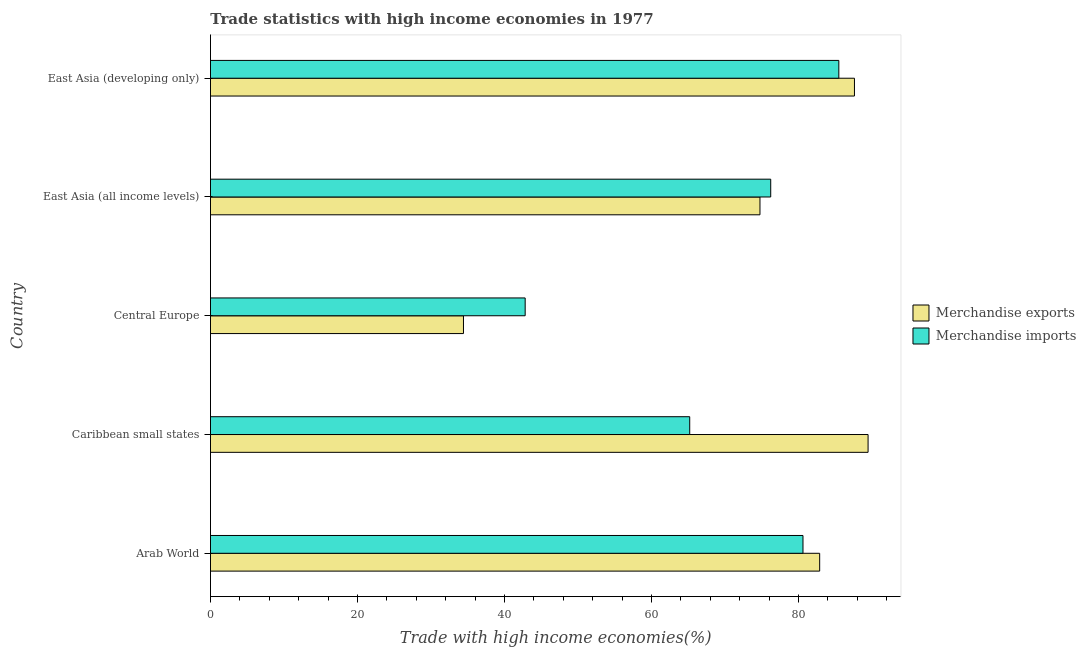How many different coloured bars are there?
Offer a terse response. 2. Are the number of bars per tick equal to the number of legend labels?
Your answer should be very brief. Yes. How many bars are there on the 3rd tick from the top?
Your answer should be compact. 2. What is the label of the 4th group of bars from the top?
Ensure brevity in your answer.  Caribbean small states. In how many cases, is the number of bars for a given country not equal to the number of legend labels?
Offer a very short reply. 0. What is the merchandise exports in East Asia (developing only)?
Offer a very short reply. 87.6. Across all countries, what is the maximum merchandise imports?
Provide a short and direct response. 85.48. Across all countries, what is the minimum merchandise imports?
Offer a very short reply. 42.81. In which country was the merchandise imports maximum?
Ensure brevity in your answer.  East Asia (developing only). In which country was the merchandise imports minimum?
Give a very brief answer. Central Europe. What is the total merchandise imports in the graph?
Offer a terse response. 350.3. What is the difference between the merchandise exports in Arab World and that in Caribbean small states?
Your answer should be very brief. -6.58. What is the difference between the merchandise imports in Central Europe and the merchandise exports in Arab World?
Your answer should be compact. -40.06. What is the average merchandise exports per country?
Provide a short and direct response. 73.82. What is the difference between the merchandise imports and merchandise exports in Arab World?
Keep it short and to the point. -2.27. In how many countries, is the merchandise exports greater than 28 %?
Your answer should be compact. 5. What is the ratio of the merchandise exports in Caribbean small states to that in East Asia (all income levels)?
Make the answer very short. 1.2. Is the difference between the merchandise imports in Caribbean small states and East Asia (developing only) greater than the difference between the merchandise exports in Caribbean small states and East Asia (developing only)?
Your response must be concise. No. What is the difference between the highest and the second highest merchandise exports?
Make the answer very short. 1.85. What is the difference between the highest and the lowest merchandise exports?
Offer a terse response. 55.04. Is the sum of the merchandise exports in Central Europe and East Asia (all income levels) greater than the maximum merchandise imports across all countries?
Your answer should be very brief. Yes. What does the 2nd bar from the top in Central Europe represents?
Provide a succinct answer. Merchandise exports. How many countries are there in the graph?
Your answer should be compact. 5. Does the graph contain any zero values?
Give a very brief answer. No. Where does the legend appear in the graph?
Offer a terse response. Center right. What is the title of the graph?
Give a very brief answer. Trade statistics with high income economies in 1977. Does "Broad money growth" appear as one of the legend labels in the graph?
Your response must be concise. No. What is the label or title of the X-axis?
Provide a short and direct response. Trade with high income economies(%). What is the label or title of the Y-axis?
Your answer should be very brief. Country. What is the Trade with high income economies(%) in Merchandise exports in Arab World?
Offer a terse response. 82.87. What is the Trade with high income economies(%) of Merchandise imports in Arab World?
Your response must be concise. 80.6. What is the Trade with high income economies(%) of Merchandise exports in Caribbean small states?
Your answer should be compact. 89.46. What is the Trade with high income economies(%) of Merchandise imports in Caribbean small states?
Keep it short and to the point. 65.19. What is the Trade with high income economies(%) in Merchandise exports in Central Europe?
Ensure brevity in your answer.  34.42. What is the Trade with high income economies(%) of Merchandise imports in Central Europe?
Make the answer very short. 42.81. What is the Trade with high income economies(%) in Merchandise exports in East Asia (all income levels)?
Offer a terse response. 74.75. What is the Trade with high income economies(%) of Merchandise imports in East Asia (all income levels)?
Your answer should be very brief. 76.21. What is the Trade with high income economies(%) of Merchandise exports in East Asia (developing only)?
Offer a terse response. 87.6. What is the Trade with high income economies(%) in Merchandise imports in East Asia (developing only)?
Provide a succinct answer. 85.48. Across all countries, what is the maximum Trade with high income economies(%) in Merchandise exports?
Your answer should be very brief. 89.46. Across all countries, what is the maximum Trade with high income economies(%) in Merchandise imports?
Make the answer very short. 85.48. Across all countries, what is the minimum Trade with high income economies(%) in Merchandise exports?
Give a very brief answer. 34.42. Across all countries, what is the minimum Trade with high income economies(%) of Merchandise imports?
Offer a terse response. 42.81. What is the total Trade with high income economies(%) of Merchandise exports in the graph?
Your response must be concise. 369.11. What is the total Trade with high income economies(%) in Merchandise imports in the graph?
Give a very brief answer. 350.3. What is the difference between the Trade with high income economies(%) of Merchandise exports in Arab World and that in Caribbean small states?
Your answer should be very brief. -6.58. What is the difference between the Trade with high income economies(%) of Merchandise imports in Arab World and that in Caribbean small states?
Make the answer very short. 15.41. What is the difference between the Trade with high income economies(%) of Merchandise exports in Arab World and that in Central Europe?
Make the answer very short. 48.46. What is the difference between the Trade with high income economies(%) in Merchandise imports in Arab World and that in Central Europe?
Offer a terse response. 37.79. What is the difference between the Trade with high income economies(%) of Merchandise exports in Arab World and that in East Asia (all income levels)?
Provide a short and direct response. 8.12. What is the difference between the Trade with high income economies(%) of Merchandise imports in Arab World and that in East Asia (all income levels)?
Ensure brevity in your answer.  4.39. What is the difference between the Trade with high income economies(%) of Merchandise exports in Arab World and that in East Asia (developing only)?
Offer a terse response. -4.73. What is the difference between the Trade with high income economies(%) of Merchandise imports in Arab World and that in East Asia (developing only)?
Give a very brief answer. -4.88. What is the difference between the Trade with high income economies(%) of Merchandise exports in Caribbean small states and that in Central Europe?
Offer a terse response. 55.04. What is the difference between the Trade with high income economies(%) of Merchandise imports in Caribbean small states and that in Central Europe?
Keep it short and to the point. 22.38. What is the difference between the Trade with high income economies(%) of Merchandise exports in Caribbean small states and that in East Asia (all income levels)?
Your answer should be very brief. 14.71. What is the difference between the Trade with high income economies(%) of Merchandise imports in Caribbean small states and that in East Asia (all income levels)?
Your answer should be compact. -11.02. What is the difference between the Trade with high income economies(%) in Merchandise exports in Caribbean small states and that in East Asia (developing only)?
Your answer should be compact. 1.85. What is the difference between the Trade with high income economies(%) of Merchandise imports in Caribbean small states and that in East Asia (developing only)?
Give a very brief answer. -20.28. What is the difference between the Trade with high income economies(%) in Merchandise exports in Central Europe and that in East Asia (all income levels)?
Your response must be concise. -40.33. What is the difference between the Trade with high income economies(%) of Merchandise imports in Central Europe and that in East Asia (all income levels)?
Your response must be concise. -33.4. What is the difference between the Trade with high income economies(%) in Merchandise exports in Central Europe and that in East Asia (developing only)?
Ensure brevity in your answer.  -53.19. What is the difference between the Trade with high income economies(%) in Merchandise imports in Central Europe and that in East Asia (developing only)?
Ensure brevity in your answer.  -42.67. What is the difference between the Trade with high income economies(%) of Merchandise exports in East Asia (all income levels) and that in East Asia (developing only)?
Provide a succinct answer. -12.85. What is the difference between the Trade with high income economies(%) of Merchandise imports in East Asia (all income levels) and that in East Asia (developing only)?
Provide a succinct answer. -9.27. What is the difference between the Trade with high income economies(%) in Merchandise exports in Arab World and the Trade with high income economies(%) in Merchandise imports in Caribbean small states?
Make the answer very short. 17.68. What is the difference between the Trade with high income economies(%) in Merchandise exports in Arab World and the Trade with high income economies(%) in Merchandise imports in Central Europe?
Offer a terse response. 40.06. What is the difference between the Trade with high income economies(%) in Merchandise exports in Arab World and the Trade with high income economies(%) in Merchandise imports in East Asia (all income levels)?
Provide a succinct answer. 6.66. What is the difference between the Trade with high income economies(%) of Merchandise exports in Arab World and the Trade with high income economies(%) of Merchandise imports in East Asia (developing only)?
Offer a very short reply. -2.6. What is the difference between the Trade with high income economies(%) of Merchandise exports in Caribbean small states and the Trade with high income economies(%) of Merchandise imports in Central Europe?
Keep it short and to the point. 46.65. What is the difference between the Trade with high income economies(%) in Merchandise exports in Caribbean small states and the Trade with high income economies(%) in Merchandise imports in East Asia (all income levels)?
Your response must be concise. 13.24. What is the difference between the Trade with high income economies(%) in Merchandise exports in Caribbean small states and the Trade with high income economies(%) in Merchandise imports in East Asia (developing only)?
Make the answer very short. 3.98. What is the difference between the Trade with high income economies(%) in Merchandise exports in Central Europe and the Trade with high income economies(%) in Merchandise imports in East Asia (all income levels)?
Make the answer very short. -41.8. What is the difference between the Trade with high income economies(%) of Merchandise exports in Central Europe and the Trade with high income economies(%) of Merchandise imports in East Asia (developing only)?
Make the answer very short. -51.06. What is the difference between the Trade with high income economies(%) of Merchandise exports in East Asia (all income levels) and the Trade with high income economies(%) of Merchandise imports in East Asia (developing only)?
Provide a succinct answer. -10.73. What is the average Trade with high income economies(%) of Merchandise exports per country?
Offer a terse response. 73.82. What is the average Trade with high income economies(%) of Merchandise imports per country?
Keep it short and to the point. 70.06. What is the difference between the Trade with high income economies(%) of Merchandise exports and Trade with high income economies(%) of Merchandise imports in Arab World?
Provide a short and direct response. 2.27. What is the difference between the Trade with high income economies(%) in Merchandise exports and Trade with high income economies(%) in Merchandise imports in Caribbean small states?
Keep it short and to the point. 24.26. What is the difference between the Trade with high income economies(%) in Merchandise exports and Trade with high income economies(%) in Merchandise imports in Central Europe?
Your answer should be very brief. -8.39. What is the difference between the Trade with high income economies(%) in Merchandise exports and Trade with high income economies(%) in Merchandise imports in East Asia (all income levels)?
Give a very brief answer. -1.46. What is the difference between the Trade with high income economies(%) of Merchandise exports and Trade with high income economies(%) of Merchandise imports in East Asia (developing only)?
Give a very brief answer. 2.13. What is the ratio of the Trade with high income economies(%) in Merchandise exports in Arab World to that in Caribbean small states?
Make the answer very short. 0.93. What is the ratio of the Trade with high income economies(%) in Merchandise imports in Arab World to that in Caribbean small states?
Give a very brief answer. 1.24. What is the ratio of the Trade with high income economies(%) of Merchandise exports in Arab World to that in Central Europe?
Offer a terse response. 2.41. What is the ratio of the Trade with high income economies(%) of Merchandise imports in Arab World to that in Central Europe?
Your answer should be very brief. 1.88. What is the ratio of the Trade with high income economies(%) in Merchandise exports in Arab World to that in East Asia (all income levels)?
Offer a terse response. 1.11. What is the ratio of the Trade with high income economies(%) in Merchandise imports in Arab World to that in East Asia (all income levels)?
Give a very brief answer. 1.06. What is the ratio of the Trade with high income economies(%) in Merchandise exports in Arab World to that in East Asia (developing only)?
Provide a succinct answer. 0.95. What is the ratio of the Trade with high income economies(%) of Merchandise imports in Arab World to that in East Asia (developing only)?
Your answer should be compact. 0.94. What is the ratio of the Trade with high income economies(%) in Merchandise exports in Caribbean small states to that in Central Europe?
Offer a terse response. 2.6. What is the ratio of the Trade with high income economies(%) of Merchandise imports in Caribbean small states to that in Central Europe?
Keep it short and to the point. 1.52. What is the ratio of the Trade with high income economies(%) of Merchandise exports in Caribbean small states to that in East Asia (all income levels)?
Provide a succinct answer. 1.2. What is the ratio of the Trade with high income economies(%) in Merchandise imports in Caribbean small states to that in East Asia (all income levels)?
Your answer should be compact. 0.86. What is the ratio of the Trade with high income economies(%) of Merchandise exports in Caribbean small states to that in East Asia (developing only)?
Offer a terse response. 1.02. What is the ratio of the Trade with high income economies(%) of Merchandise imports in Caribbean small states to that in East Asia (developing only)?
Your answer should be very brief. 0.76. What is the ratio of the Trade with high income economies(%) in Merchandise exports in Central Europe to that in East Asia (all income levels)?
Your answer should be very brief. 0.46. What is the ratio of the Trade with high income economies(%) of Merchandise imports in Central Europe to that in East Asia (all income levels)?
Give a very brief answer. 0.56. What is the ratio of the Trade with high income economies(%) in Merchandise exports in Central Europe to that in East Asia (developing only)?
Provide a succinct answer. 0.39. What is the ratio of the Trade with high income economies(%) in Merchandise imports in Central Europe to that in East Asia (developing only)?
Your answer should be very brief. 0.5. What is the ratio of the Trade with high income economies(%) in Merchandise exports in East Asia (all income levels) to that in East Asia (developing only)?
Ensure brevity in your answer.  0.85. What is the ratio of the Trade with high income economies(%) in Merchandise imports in East Asia (all income levels) to that in East Asia (developing only)?
Keep it short and to the point. 0.89. What is the difference between the highest and the second highest Trade with high income economies(%) of Merchandise exports?
Ensure brevity in your answer.  1.85. What is the difference between the highest and the second highest Trade with high income economies(%) in Merchandise imports?
Give a very brief answer. 4.88. What is the difference between the highest and the lowest Trade with high income economies(%) of Merchandise exports?
Provide a succinct answer. 55.04. What is the difference between the highest and the lowest Trade with high income economies(%) of Merchandise imports?
Your response must be concise. 42.67. 